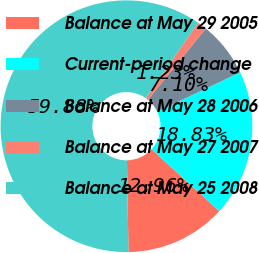Convert chart to OTSL. <chart><loc_0><loc_0><loc_500><loc_500><pie_chart><fcel>Balance at May 29 2005<fcel>Current-period change<fcel>Balance at May 28 2006<fcel>Balance at May 27 2007<fcel>Balance at May 25 2008<nl><fcel>12.96%<fcel>18.83%<fcel>7.1%<fcel>1.23%<fcel>59.88%<nl></chart> 